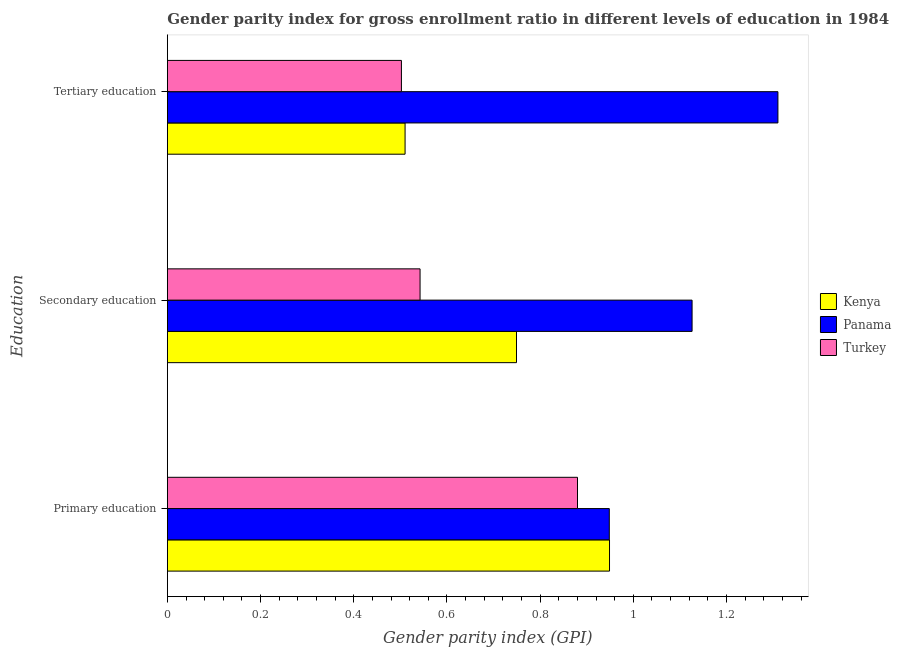How many different coloured bars are there?
Offer a terse response. 3. Are the number of bars per tick equal to the number of legend labels?
Make the answer very short. Yes. Are the number of bars on each tick of the Y-axis equal?
Provide a short and direct response. Yes. How many bars are there on the 3rd tick from the bottom?
Offer a very short reply. 3. What is the gender parity index in primary education in Turkey?
Offer a very short reply. 0.88. Across all countries, what is the maximum gender parity index in tertiary education?
Offer a very short reply. 1.31. Across all countries, what is the minimum gender parity index in tertiary education?
Your answer should be compact. 0.5. In which country was the gender parity index in secondary education maximum?
Your response must be concise. Panama. In which country was the gender parity index in tertiary education minimum?
Your answer should be compact. Turkey. What is the total gender parity index in primary education in the graph?
Offer a very short reply. 2.78. What is the difference between the gender parity index in primary education in Kenya and that in Turkey?
Your answer should be very brief. 0.07. What is the difference between the gender parity index in tertiary education in Kenya and the gender parity index in secondary education in Panama?
Ensure brevity in your answer.  -0.62. What is the average gender parity index in primary education per country?
Your answer should be very brief. 0.93. What is the difference between the gender parity index in tertiary education and gender parity index in secondary education in Kenya?
Provide a short and direct response. -0.24. In how many countries, is the gender parity index in secondary education greater than 0.8400000000000001 ?
Ensure brevity in your answer.  1. What is the ratio of the gender parity index in secondary education in Panama to that in Turkey?
Offer a terse response. 2.08. Is the difference between the gender parity index in secondary education in Panama and Kenya greater than the difference between the gender parity index in primary education in Panama and Kenya?
Make the answer very short. Yes. What is the difference between the highest and the second highest gender parity index in primary education?
Ensure brevity in your answer.  0. What is the difference between the highest and the lowest gender parity index in tertiary education?
Provide a succinct answer. 0.81. Is the sum of the gender parity index in primary education in Turkey and Panama greater than the maximum gender parity index in secondary education across all countries?
Keep it short and to the point. Yes. What does the 1st bar from the top in Secondary education represents?
Your response must be concise. Turkey. What does the 2nd bar from the bottom in Tertiary education represents?
Your response must be concise. Panama. Are all the bars in the graph horizontal?
Your response must be concise. Yes. Are the values on the major ticks of X-axis written in scientific E-notation?
Make the answer very short. No. Does the graph contain any zero values?
Offer a very short reply. No. How many legend labels are there?
Provide a short and direct response. 3. How are the legend labels stacked?
Make the answer very short. Vertical. What is the title of the graph?
Your answer should be very brief. Gender parity index for gross enrollment ratio in different levels of education in 1984. Does "Latin America(developing only)" appear as one of the legend labels in the graph?
Your answer should be very brief. No. What is the label or title of the X-axis?
Your answer should be very brief. Gender parity index (GPI). What is the label or title of the Y-axis?
Ensure brevity in your answer.  Education. What is the Gender parity index (GPI) in Kenya in Primary education?
Make the answer very short. 0.95. What is the Gender parity index (GPI) of Panama in Primary education?
Make the answer very short. 0.95. What is the Gender parity index (GPI) of Turkey in Primary education?
Offer a very short reply. 0.88. What is the Gender parity index (GPI) of Kenya in Secondary education?
Offer a terse response. 0.75. What is the Gender parity index (GPI) in Panama in Secondary education?
Your answer should be very brief. 1.13. What is the Gender parity index (GPI) of Turkey in Secondary education?
Make the answer very short. 0.54. What is the Gender parity index (GPI) in Kenya in Tertiary education?
Make the answer very short. 0.51. What is the Gender parity index (GPI) of Panama in Tertiary education?
Make the answer very short. 1.31. What is the Gender parity index (GPI) in Turkey in Tertiary education?
Your response must be concise. 0.5. Across all Education, what is the maximum Gender parity index (GPI) of Kenya?
Provide a short and direct response. 0.95. Across all Education, what is the maximum Gender parity index (GPI) of Panama?
Provide a short and direct response. 1.31. Across all Education, what is the maximum Gender parity index (GPI) in Turkey?
Offer a terse response. 0.88. Across all Education, what is the minimum Gender parity index (GPI) in Kenya?
Offer a very short reply. 0.51. Across all Education, what is the minimum Gender parity index (GPI) in Panama?
Offer a terse response. 0.95. Across all Education, what is the minimum Gender parity index (GPI) of Turkey?
Your response must be concise. 0.5. What is the total Gender parity index (GPI) in Kenya in the graph?
Keep it short and to the point. 2.21. What is the total Gender parity index (GPI) of Panama in the graph?
Keep it short and to the point. 3.38. What is the total Gender parity index (GPI) of Turkey in the graph?
Your answer should be very brief. 1.92. What is the difference between the Gender parity index (GPI) of Kenya in Primary education and that in Secondary education?
Provide a short and direct response. 0.2. What is the difference between the Gender parity index (GPI) in Panama in Primary education and that in Secondary education?
Keep it short and to the point. -0.18. What is the difference between the Gender parity index (GPI) in Turkey in Primary education and that in Secondary education?
Offer a terse response. 0.34. What is the difference between the Gender parity index (GPI) of Kenya in Primary education and that in Tertiary education?
Provide a short and direct response. 0.44. What is the difference between the Gender parity index (GPI) of Panama in Primary education and that in Tertiary education?
Offer a very short reply. -0.36. What is the difference between the Gender parity index (GPI) of Turkey in Primary education and that in Tertiary education?
Provide a short and direct response. 0.38. What is the difference between the Gender parity index (GPI) in Kenya in Secondary education and that in Tertiary education?
Your answer should be compact. 0.24. What is the difference between the Gender parity index (GPI) of Panama in Secondary education and that in Tertiary education?
Make the answer very short. -0.18. What is the difference between the Gender parity index (GPI) in Kenya in Primary education and the Gender parity index (GPI) in Panama in Secondary education?
Give a very brief answer. -0.18. What is the difference between the Gender parity index (GPI) of Kenya in Primary education and the Gender parity index (GPI) of Turkey in Secondary education?
Give a very brief answer. 0.41. What is the difference between the Gender parity index (GPI) of Panama in Primary education and the Gender parity index (GPI) of Turkey in Secondary education?
Offer a terse response. 0.41. What is the difference between the Gender parity index (GPI) in Kenya in Primary education and the Gender parity index (GPI) in Panama in Tertiary education?
Your response must be concise. -0.36. What is the difference between the Gender parity index (GPI) in Kenya in Primary education and the Gender parity index (GPI) in Turkey in Tertiary education?
Offer a terse response. 0.45. What is the difference between the Gender parity index (GPI) of Panama in Primary education and the Gender parity index (GPI) of Turkey in Tertiary education?
Make the answer very short. 0.45. What is the difference between the Gender parity index (GPI) in Kenya in Secondary education and the Gender parity index (GPI) in Panama in Tertiary education?
Ensure brevity in your answer.  -0.56. What is the difference between the Gender parity index (GPI) in Kenya in Secondary education and the Gender parity index (GPI) in Turkey in Tertiary education?
Give a very brief answer. 0.25. What is the difference between the Gender parity index (GPI) of Panama in Secondary education and the Gender parity index (GPI) of Turkey in Tertiary education?
Your answer should be very brief. 0.62. What is the average Gender parity index (GPI) of Kenya per Education?
Provide a succinct answer. 0.74. What is the average Gender parity index (GPI) of Panama per Education?
Provide a short and direct response. 1.13. What is the average Gender parity index (GPI) in Turkey per Education?
Keep it short and to the point. 0.64. What is the difference between the Gender parity index (GPI) of Kenya and Gender parity index (GPI) of Turkey in Primary education?
Give a very brief answer. 0.07. What is the difference between the Gender parity index (GPI) in Panama and Gender parity index (GPI) in Turkey in Primary education?
Give a very brief answer. 0.07. What is the difference between the Gender parity index (GPI) of Kenya and Gender parity index (GPI) of Panama in Secondary education?
Provide a short and direct response. -0.38. What is the difference between the Gender parity index (GPI) of Kenya and Gender parity index (GPI) of Turkey in Secondary education?
Keep it short and to the point. 0.21. What is the difference between the Gender parity index (GPI) in Panama and Gender parity index (GPI) in Turkey in Secondary education?
Give a very brief answer. 0.58. What is the difference between the Gender parity index (GPI) in Kenya and Gender parity index (GPI) in Panama in Tertiary education?
Offer a very short reply. -0.8. What is the difference between the Gender parity index (GPI) in Kenya and Gender parity index (GPI) in Turkey in Tertiary education?
Your answer should be very brief. 0.01. What is the difference between the Gender parity index (GPI) in Panama and Gender parity index (GPI) in Turkey in Tertiary education?
Keep it short and to the point. 0.81. What is the ratio of the Gender parity index (GPI) of Kenya in Primary education to that in Secondary education?
Offer a very short reply. 1.27. What is the ratio of the Gender parity index (GPI) in Panama in Primary education to that in Secondary education?
Give a very brief answer. 0.84. What is the ratio of the Gender parity index (GPI) in Turkey in Primary education to that in Secondary education?
Offer a very short reply. 1.62. What is the ratio of the Gender parity index (GPI) of Kenya in Primary education to that in Tertiary education?
Your response must be concise. 1.86. What is the ratio of the Gender parity index (GPI) in Panama in Primary education to that in Tertiary education?
Offer a terse response. 0.72. What is the ratio of the Gender parity index (GPI) of Turkey in Primary education to that in Tertiary education?
Offer a very short reply. 1.75. What is the ratio of the Gender parity index (GPI) in Kenya in Secondary education to that in Tertiary education?
Keep it short and to the point. 1.47. What is the ratio of the Gender parity index (GPI) of Panama in Secondary education to that in Tertiary education?
Provide a short and direct response. 0.86. What is the ratio of the Gender parity index (GPI) in Turkey in Secondary education to that in Tertiary education?
Your response must be concise. 1.08. What is the difference between the highest and the second highest Gender parity index (GPI) in Kenya?
Keep it short and to the point. 0.2. What is the difference between the highest and the second highest Gender parity index (GPI) of Panama?
Your answer should be very brief. 0.18. What is the difference between the highest and the second highest Gender parity index (GPI) in Turkey?
Your answer should be compact. 0.34. What is the difference between the highest and the lowest Gender parity index (GPI) of Kenya?
Your answer should be very brief. 0.44. What is the difference between the highest and the lowest Gender parity index (GPI) of Panama?
Offer a very short reply. 0.36. What is the difference between the highest and the lowest Gender parity index (GPI) in Turkey?
Provide a succinct answer. 0.38. 